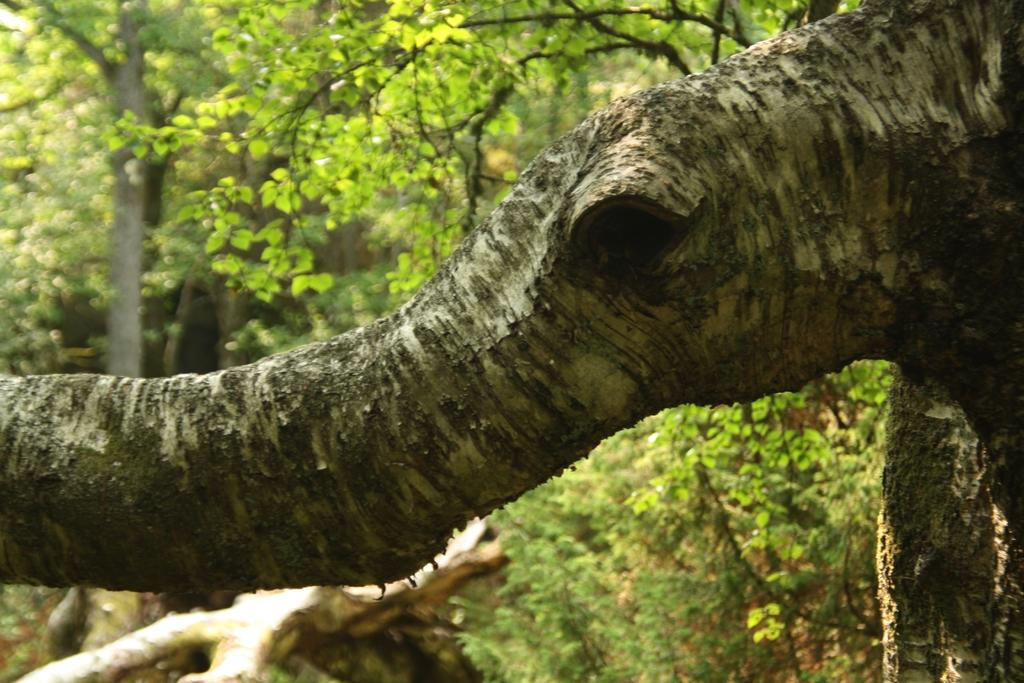What is the primary feature of the image? The primary feature of the image is the presence of many trees. Can you describe any specific part of a tree that is visible in the image? Yes, the trunk of a tree is visible in the image. What type of tooth can be seen in the image? There is no tooth present in the image; it features many trees and a visible tree trunk. 